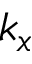Convert formula to latex. <formula><loc_0><loc_0><loc_500><loc_500>k _ { x }</formula> 